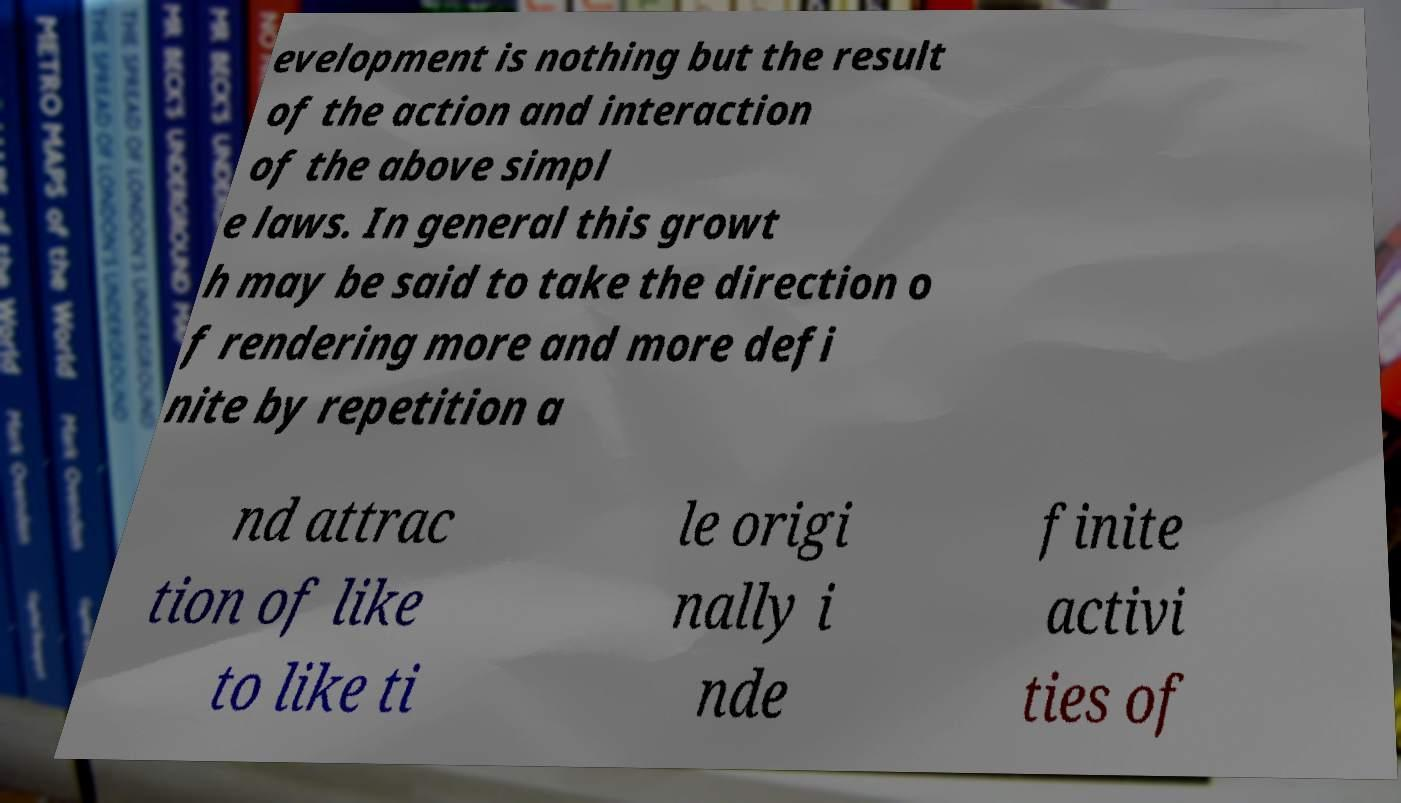Please read and relay the text visible in this image. What does it say? evelopment is nothing but the result of the action and interaction of the above simpl e laws. In general this growt h may be said to take the direction o f rendering more and more defi nite by repetition a nd attrac tion of like to like ti le origi nally i nde finite activi ties of 